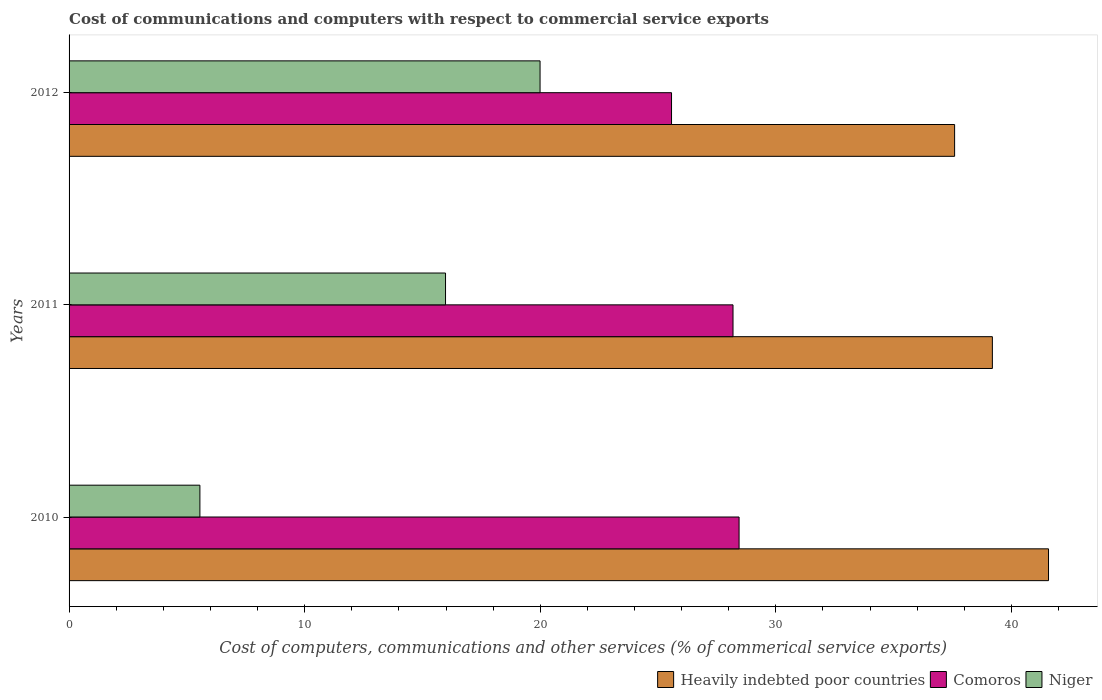How many groups of bars are there?
Offer a terse response. 3. How many bars are there on the 2nd tick from the top?
Offer a terse response. 3. How many bars are there on the 2nd tick from the bottom?
Your answer should be compact. 3. What is the label of the 2nd group of bars from the top?
Provide a short and direct response. 2011. What is the cost of communications and computers in Niger in 2012?
Make the answer very short. 19.99. Across all years, what is the maximum cost of communications and computers in Heavily indebted poor countries?
Provide a succinct answer. 41.58. Across all years, what is the minimum cost of communications and computers in Comoros?
Provide a succinct answer. 25.57. In which year was the cost of communications and computers in Niger minimum?
Ensure brevity in your answer.  2010. What is the total cost of communications and computers in Niger in the graph?
Offer a very short reply. 41.53. What is the difference between the cost of communications and computers in Comoros in 2011 and that in 2012?
Give a very brief answer. 2.61. What is the difference between the cost of communications and computers in Niger in 2010 and the cost of communications and computers in Comoros in 2011?
Offer a very short reply. -22.63. What is the average cost of communications and computers in Niger per year?
Ensure brevity in your answer.  13.84. In the year 2012, what is the difference between the cost of communications and computers in Heavily indebted poor countries and cost of communications and computers in Niger?
Provide a short and direct response. 17.6. What is the ratio of the cost of communications and computers in Niger in 2011 to that in 2012?
Make the answer very short. 0.8. What is the difference between the highest and the second highest cost of communications and computers in Comoros?
Give a very brief answer. 0.26. What is the difference between the highest and the lowest cost of communications and computers in Heavily indebted poor countries?
Give a very brief answer. 3.99. In how many years, is the cost of communications and computers in Comoros greater than the average cost of communications and computers in Comoros taken over all years?
Ensure brevity in your answer.  2. What does the 3rd bar from the top in 2011 represents?
Your answer should be compact. Heavily indebted poor countries. What does the 2nd bar from the bottom in 2010 represents?
Offer a terse response. Comoros. Is it the case that in every year, the sum of the cost of communications and computers in Comoros and cost of communications and computers in Heavily indebted poor countries is greater than the cost of communications and computers in Niger?
Ensure brevity in your answer.  Yes. Are all the bars in the graph horizontal?
Your response must be concise. Yes. Are the values on the major ticks of X-axis written in scientific E-notation?
Ensure brevity in your answer.  No. Does the graph contain grids?
Offer a terse response. No. How many legend labels are there?
Ensure brevity in your answer.  3. What is the title of the graph?
Provide a short and direct response. Cost of communications and computers with respect to commercial service exports. Does "Tajikistan" appear as one of the legend labels in the graph?
Ensure brevity in your answer.  No. What is the label or title of the X-axis?
Your response must be concise. Cost of computers, communications and other services (% of commerical service exports). What is the Cost of computers, communications and other services (% of commerical service exports) in Heavily indebted poor countries in 2010?
Your answer should be very brief. 41.58. What is the Cost of computers, communications and other services (% of commerical service exports) in Comoros in 2010?
Provide a short and direct response. 28.44. What is the Cost of computers, communications and other services (% of commerical service exports) of Niger in 2010?
Make the answer very short. 5.55. What is the Cost of computers, communications and other services (% of commerical service exports) in Heavily indebted poor countries in 2011?
Provide a short and direct response. 39.19. What is the Cost of computers, communications and other services (% of commerical service exports) of Comoros in 2011?
Provide a succinct answer. 28.18. What is the Cost of computers, communications and other services (% of commerical service exports) of Niger in 2011?
Keep it short and to the point. 15.98. What is the Cost of computers, communications and other services (% of commerical service exports) in Heavily indebted poor countries in 2012?
Your response must be concise. 37.59. What is the Cost of computers, communications and other services (% of commerical service exports) in Comoros in 2012?
Offer a terse response. 25.57. What is the Cost of computers, communications and other services (% of commerical service exports) in Niger in 2012?
Provide a short and direct response. 19.99. Across all years, what is the maximum Cost of computers, communications and other services (% of commerical service exports) in Heavily indebted poor countries?
Provide a short and direct response. 41.58. Across all years, what is the maximum Cost of computers, communications and other services (% of commerical service exports) of Comoros?
Your answer should be very brief. 28.44. Across all years, what is the maximum Cost of computers, communications and other services (% of commerical service exports) in Niger?
Keep it short and to the point. 19.99. Across all years, what is the minimum Cost of computers, communications and other services (% of commerical service exports) in Heavily indebted poor countries?
Make the answer very short. 37.59. Across all years, what is the minimum Cost of computers, communications and other services (% of commerical service exports) of Comoros?
Your answer should be compact. 25.57. Across all years, what is the minimum Cost of computers, communications and other services (% of commerical service exports) in Niger?
Your answer should be compact. 5.55. What is the total Cost of computers, communications and other services (% of commerical service exports) in Heavily indebted poor countries in the graph?
Your answer should be very brief. 118.36. What is the total Cost of computers, communications and other services (% of commerical service exports) of Comoros in the graph?
Provide a short and direct response. 82.2. What is the total Cost of computers, communications and other services (% of commerical service exports) of Niger in the graph?
Offer a terse response. 41.53. What is the difference between the Cost of computers, communications and other services (% of commerical service exports) in Heavily indebted poor countries in 2010 and that in 2011?
Keep it short and to the point. 2.38. What is the difference between the Cost of computers, communications and other services (% of commerical service exports) of Comoros in 2010 and that in 2011?
Your response must be concise. 0.26. What is the difference between the Cost of computers, communications and other services (% of commerical service exports) of Niger in 2010 and that in 2011?
Provide a short and direct response. -10.43. What is the difference between the Cost of computers, communications and other services (% of commerical service exports) of Heavily indebted poor countries in 2010 and that in 2012?
Keep it short and to the point. 3.99. What is the difference between the Cost of computers, communications and other services (% of commerical service exports) in Comoros in 2010 and that in 2012?
Offer a very short reply. 2.87. What is the difference between the Cost of computers, communications and other services (% of commerical service exports) in Niger in 2010 and that in 2012?
Make the answer very short. -14.44. What is the difference between the Cost of computers, communications and other services (% of commerical service exports) of Heavily indebted poor countries in 2011 and that in 2012?
Provide a short and direct response. 1.6. What is the difference between the Cost of computers, communications and other services (% of commerical service exports) of Comoros in 2011 and that in 2012?
Keep it short and to the point. 2.61. What is the difference between the Cost of computers, communications and other services (% of commerical service exports) in Niger in 2011 and that in 2012?
Provide a succinct answer. -4.01. What is the difference between the Cost of computers, communications and other services (% of commerical service exports) in Heavily indebted poor countries in 2010 and the Cost of computers, communications and other services (% of commerical service exports) in Comoros in 2011?
Keep it short and to the point. 13.39. What is the difference between the Cost of computers, communications and other services (% of commerical service exports) of Heavily indebted poor countries in 2010 and the Cost of computers, communications and other services (% of commerical service exports) of Niger in 2011?
Your answer should be compact. 25.6. What is the difference between the Cost of computers, communications and other services (% of commerical service exports) in Comoros in 2010 and the Cost of computers, communications and other services (% of commerical service exports) in Niger in 2011?
Keep it short and to the point. 12.46. What is the difference between the Cost of computers, communications and other services (% of commerical service exports) of Heavily indebted poor countries in 2010 and the Cost of computers, communications and other services (% of commerical service exports) of Comoros in 2012?
Ensure brevity in your answer.  16. What is the difference between the Cost of computers, communications and other services (% of commerical service exports) of Heavily indebted poor countries in 2010 and the Cost of computers, communications and other services (% of commerical service exports) of Niger in 2012?
Give a very brief answer. 21.58. What is the difference between the Cost of computers, communications and other services (% of commerical service exports) of Comoros in 2010 and the Cost of computers, communications and other services (% of commerical service exports) of Niger in 2012?
Offer a terse response. 8.45. What is the difference between the Cost of computers, communications and other services (% of commerical service exports) of Heavily indebted poor countries in 2011 and the Cost of computers, communications and other services (% of commerical service exports) of Comoros in 2012?
Your answer should be compact. 13.62. What is the difference between the Cost of computers, communications and other services (% of commerical service exports) of Heavily indebted poor countries in 2011 and the Cost of computers, communications and other services (% of commerical service exports) of Niger in 2012?
Provide a short and direct response. 19.2. What is the difference between the Cost of computers, communications and other services (% of commerical service exports) of Comoros in 2011 and the Cost of computers, communications and other services (% of commerical service exports) of Niger in 2012?
Give a very brief answer. 8.19. What is the average Cost of computers, communications and other services (% of commerical service exports) of Heavily indebted poor countries per year?
Your response must be concise. 39.45. What is the average Cost of computers, communications and other services (% of commerical service exports) in Comoros per year?
Make the answer very short. 27.4. What is the average Cost of computers, communications and other services (% of commerical service exports) in Niger per year?
Make the answer very short. 13.84. In the year 2010, what is the difference between the Cost of computers, communications and other services (% of commerical service exports) in Heavily indebted poor countries and Cost of computers, communications and other services (% of commerical service exports) in Comoros?
Offer a terse response. 13.14. In the year 2010, what is the difference between the Cost of computers, communications and other services (% of commerical service exports) in Heavily indebted poor countries and Cost of computers, communications and other services (% of commerical service exports) in Niger?
Your response must be concise. 36.02. In the year 2010, what is the difference between the Cost of computers, communications and other services (% of commerical service exports) in Comoros and Cost of computers, communications and other services (% of commerical service exports) in Niger?
Provide a succinct answer. 22.89. In the year 2011, what is the difference between the Cost of computers, communications and other services (% of commerical service exports) in Heavily indebted poor countries and Cost of computers, communications and other services (% of commerical service exports) in Comoros?
Give a very brief answer. 11.01. In the year 2011, what is the difference between the Cost of computers, communications and other services (% of commerical service exports) in Heavily indebted poor countries and Cost of computers, communications and other services (% of commerical service exports) in Niger?
Provide a succinct answer. 23.21. In the year 2011, what is the difference between the Cost of computers, communications and other services (% of commerical service exports) in Comoros and Cost of computers, communications and other services (% of commerical service exports) in Niger?
Your answer should be very brief. 12.2. In the year 2012, what is the difference between the Cost of computers, communications and other services (% of commerical service exports) of Heavily indebted poor countries and Cost of computers, communications and other services (% of commerical service exports) of Comoros?
Ensure brevity in your answer.  12.02. In the year 2012, what is the difference between the Cost of computers, communications and other services (% of commerical service exports) in Heavily indebted poor countries and Cost of computers, communications and other services (% of commerical service exports) in Niger?
Provide a short and direct response. 17.6. In the year 2012, what is the difference between the Cost of computers, communications and other services (% of commerical service exports) of Comoros and Cost of computers, communications and other services (% of commerical service exports) of Niger?
Your answer should be compact. 5.58. What is the ratio of the Cost of computers, communications and other services (% of commerical service exports) in Heavily indebted poor countries in 2010 to that in 2011?
Make the answer very short. 1.06. What is the ratio of the Cost of computers, communications and other services (% of commerical service exports) of Comoros in 2010 to that in 2011?
Ensure brevity in your answer.  1.01. What is the ratio of the Cost of computers, communications and other services (% of commerical service exports) of Niger in 2010 to that in 2011?
Your response must be concise. 0.35. What is the ratio of the Cost of computers, communications and other services (% of commerical service exports) in Heavily indebted poor countries in 2010 to that in 2012?
Ensure brevity in your answer.  1.11. What is the ratio of the Cost of computers, communications and other services (% of commerical service exports) of Comoros in 2010 to that in 2012?
Make the answer very short. 1.11. What is the ratio of the Cost of computers, communications and other services (% of commerical service exports) in Niger in 2010 to that in 2012?
Your answer should be compact. 0.28. What is the ratio of the Cost of computers, communications and other services (% of commerical service exports) in Heavily indebted poor countries in 2011 to that in 2012?
Keep it short and to the point. 1.04. What is the ratio of the Cost of computers, communications and other services (% of commerical service exports) of Comoros in 2011 to that in 2012?
Provide a short and direct response. 1.1. What is the ratio of the Cost of computers, communications and other services (% of commerical service exports) in Niger in 2011 to that in 2012?
Keep it short and to the point. 0.8. What is the difference between the highest and the second highest Cost of computers, communications and other services (% of commerical service exports) in Heavily indebted poor countries?
Your response must be concise. 2.38. What is the difference between the highest and the second highest Cost of computers, communications and other services (% of commerical service exports) in Comoros?
Keep it short and to the point. 0.26. What is the difference between the highest and the second highest Cost of computers, communications and other services (% of commerical service exports) in Niger?
Provide a succinct answer. 4.01. What is the difference between the highest and the lowest Cost of computers, communications and other services (% of commerical service exports) in Heavily indebted poor countries?
Your answer should be compact. 3.99. What is the difference between the highest and the lowest Cost of computers, communications and other services (% of commerical service exports) of Comoros?
Provide a succinct answer. 2.87. What is the difference between the highest and the lowest Cost of computers, communications and other services (% of commerical service exports) of Niger?
Make the answer very short. 14.44. 